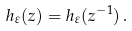Convert formula to latex. <formula><loc_0><loc_0><loc_500><loc_500>h _ { \varepsilon } ( z ) = h _ { \varepsilon } ( z ^ { - 1 } ) \, .</formula> 